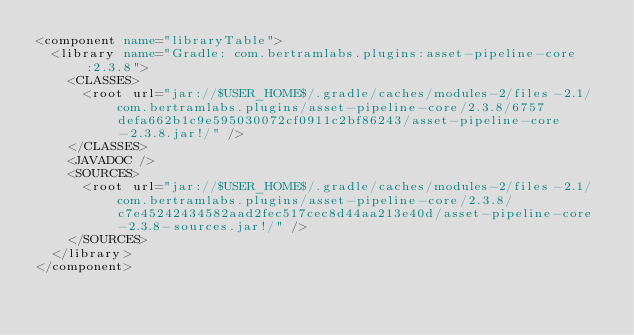Convert code to text. <code><loc_0><loc_0><loc_500><loc_500><_XML_><component name="libraryTable">
  <library name="Gradle: com.bertramlabs.plugins:asset-pipeline-core:2.3.8">
    <CLASSES>
      <root url="jar://$USER_HOME$/.gradle/caches/modules-2/files-2.1/com.bertramlabs.plugins/asset-pipeline-core/2.3.8/6757defa662b1c9e595030072cf0911c2bf86243/asset-pipeline-core-2.3.8.jar!/" />
    </CLASSES>
    <JAVADOC />
    <SOURCES>
      <root url="jar://$USER_HOME$/.gradle/caches/modules-2/files-2.1/com.bertramlabs.plugins/asset-pipeline-core/2.3.8/c7e45242434582aad2fec517cec8d44aa213e40d/asset-pipeline-core-2.3.8-sources.jar!/" />
    </SOURCES>
  </library>
</component></code> 